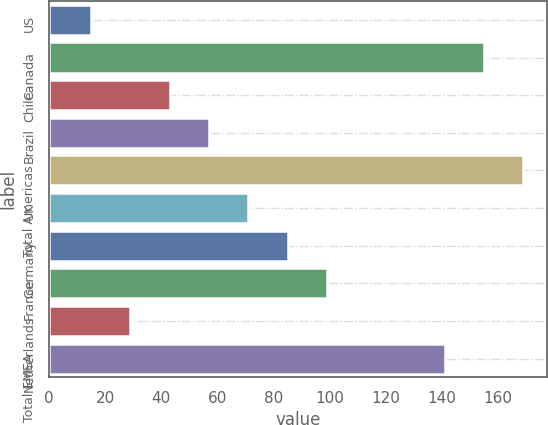Convert chart to OTSL. <chart><loc_0><loc_0><loc_500><loc_500><bar_chart><fcel>US<fcel>Canada<fcel>Chile<fcel>Brazil<fcel>Total Americas<fcel>UK<fcel>Germany<fcel>France<fcel>Netherlands<fcel>Total EMEA<nl><fcel>15<fcel>155<fcel>43<fcel>57<fcel>169<fcel>71<fcel>85<fcel>99<fcel>29<fcel>141<nl></chart> 